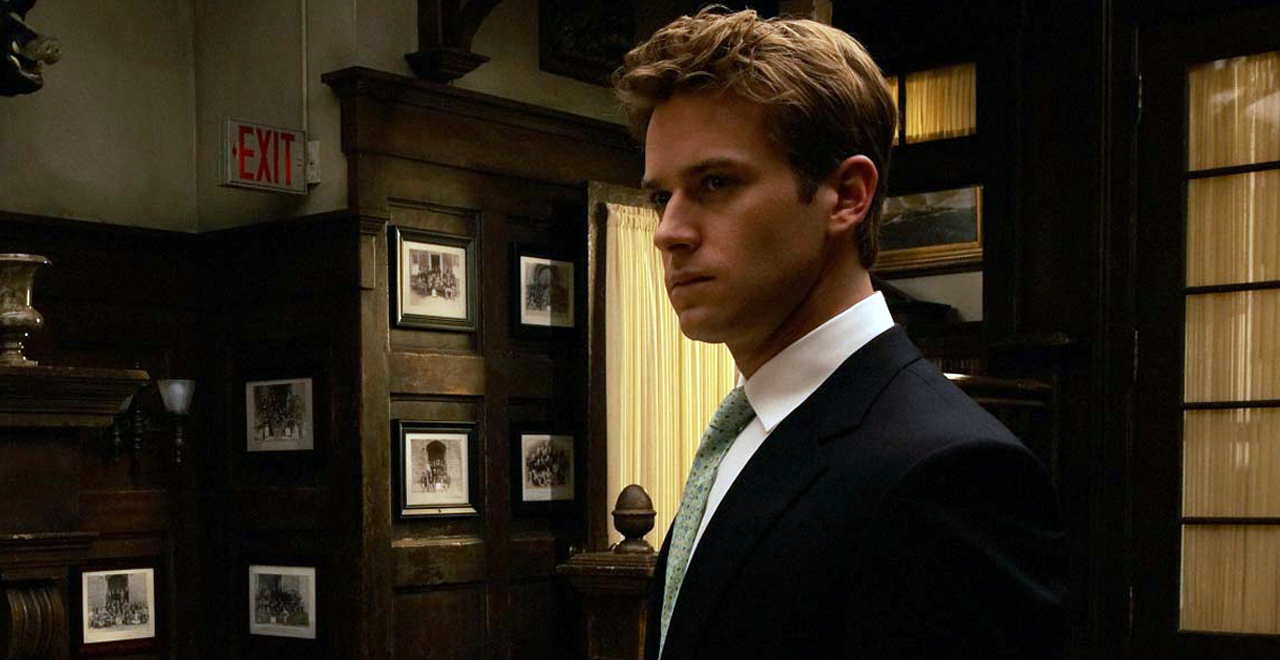How does the lighting affect the mood of the scene? The dim lighting in the scene casts shadows that complement the serious, somber mood. It enhances the mysterious and introspective qualities of the setting, focusing attention on the character and his thoughtful demeanor. 